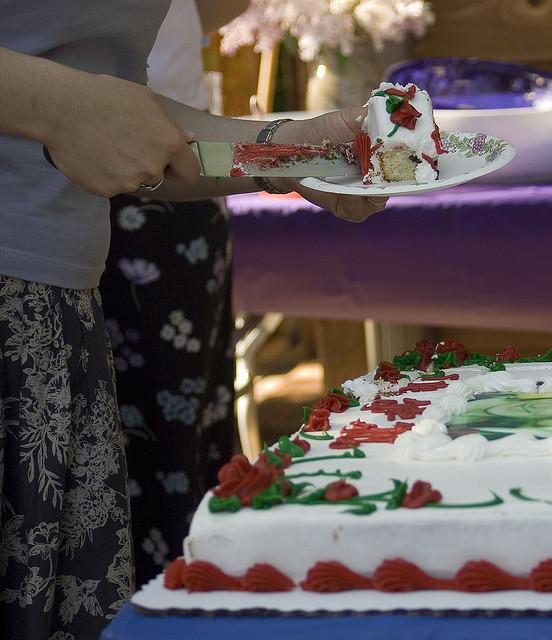Do you think this cake is beautiful?
Give a very brief answer. Yes. Are there candles on the cake?
Short answer required. No. What design is on the skirt?
Short answer required. Flowers. What kind of cake is it?
Be succinct. White. 